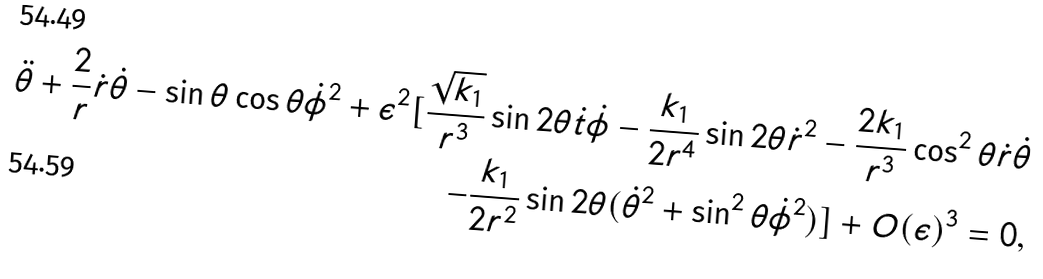<formula> <loc_0><loc_0><loc_500><loc_500>\ddot { \theta } + \frac { 2 } { r } \dot { r } \dot { \theta } - \sin \theta \cos \theta \dot { \phi } ^ { 2 } + \epsilon ^ { 2 } [ \frac { \sqrt { k _ { 1 } } } { r ^ { 3 } } \sin 2 \theta \dot { t } \dot { \phi } - \frac { k _ { 1 } } { { 2 } r ^ { 4 } } \sin 2 \theta \dot { r } ^ { 2 } - \frac { 2 { k _ { 1 } } } { r ^ { 3 } } \cos ^ { 2 } \theta \dot { r } \dot { \theta } \\ - \frac { k _ { 1 } } { { 2 } r ^ { 2 } } \sin 2 { \theta } ( \dot { \theta } ^ { 2 } + \sin ^ { 2 } { \theta } \dot { \phi } ^ { 2 } ) ] + O ( \epsilon ) ^ { 3 } = 0 ,</formula> 